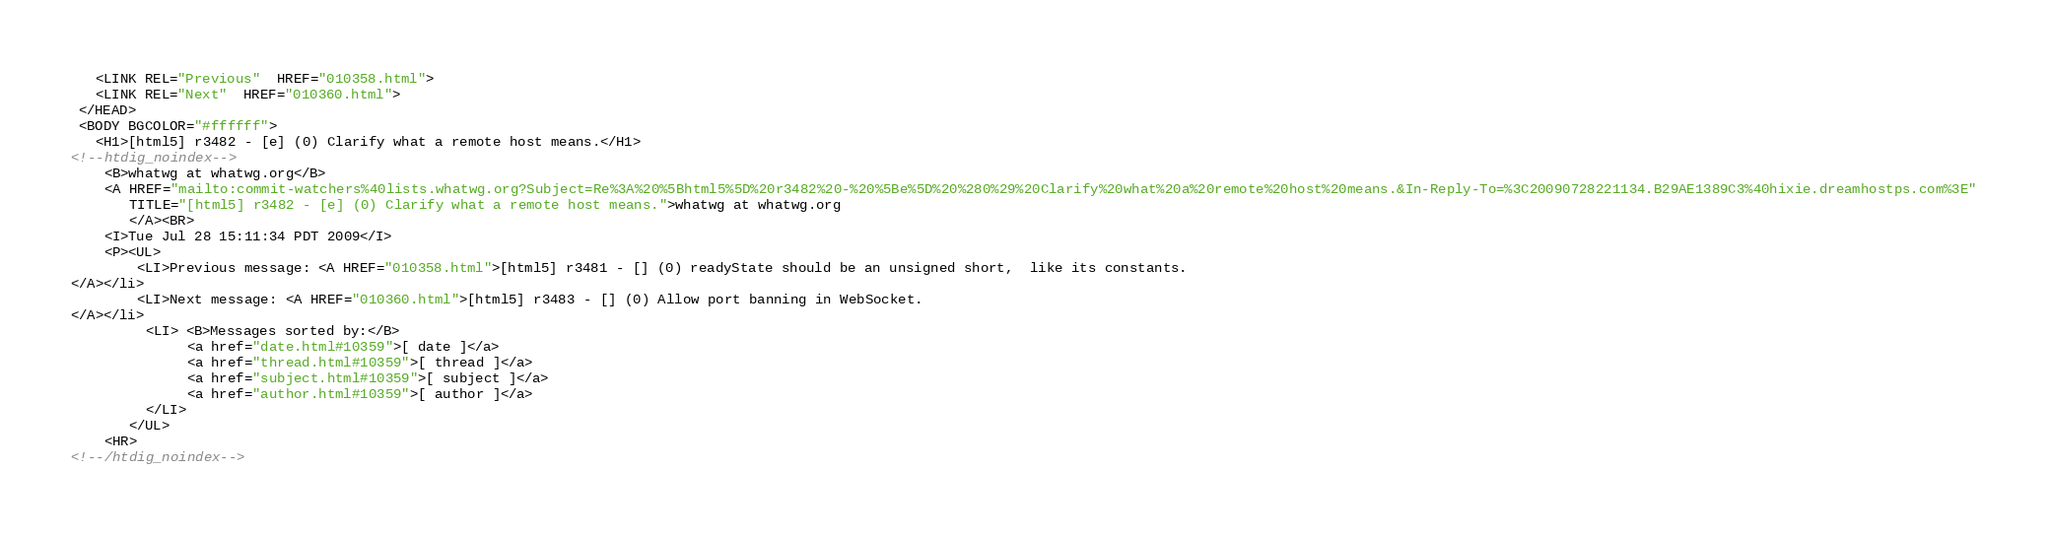<code> <loc_0><loc_0><loc_500><loc_500><_HTML_>   <LINK REL="Previous"  HREF="010358.html">
   <LINK REL="Next"  HREF="010360.html">
 </HEAD>
 <BODY BGCOLOR="#ffffff">
   <H1>[html5] r3482 - [e] (0) Clarify what a remote host means.</H1>
<!--htdig_noindex-->
    <B>whatwg at whatwg.org</B> 
    <A HREF="mailto:commit-watchers%40lists.whatwg.org?Subject=Re%3A%20%5Bhtml5%5D%20r3482%20-%20%5Be%5D%20%280%29%20Clarify%20what%20a%20remote%20host%20means.&In-Reply-To=%3C20090728221134.B29AE1389C3%40hixie.dreamhostps.com%3E"
       TITLE="[html5] r3482 - [e] (0) Clarify what a remote host means.">whatwg at whatwg.org
       </A><BR>
    <I>Tue Jul 28 15:11:34 PDT 2009</I>
    <P><UL>
        <LI>Previous message: <A HREF="010358.html">[html5] r3481 - [] (0) readyState should be an unsigned short,	like its constants.
</A></li>
        <LI>Next message: <A HREF="010360.html">[html5] r3483 - [] (0) Allow port banning in WebSocket.
</A></li>
         <LI> <B>Messages sorted by:</B> 
              <a href="date.html#10359">[ date ]</a>
              <a href="thread.html#10359">[ thread ]</a>
              <a href="subject.html#10359">[ subject ]</a>
              <a href="author.html#10359">[ author ]</a>
         </LI>
       </UL>
    <HR>  
<!--/htdig_noindex--></code> 